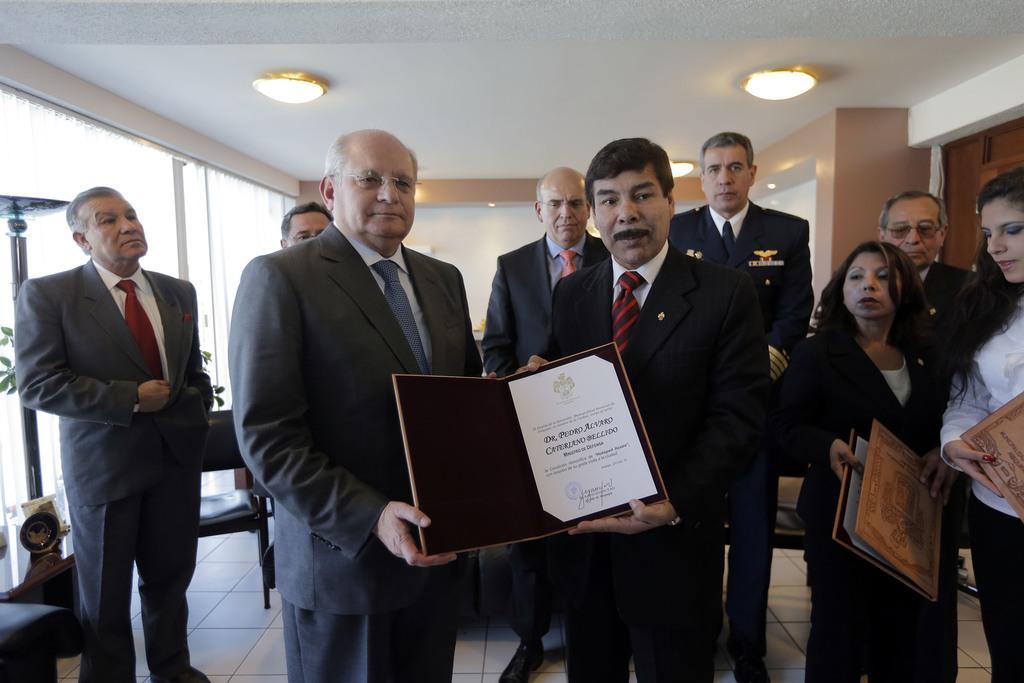How would you summarize this image in a sentence or two? In this picture I can see two persons standing and holding a padded certificate, there are group of people standing, there are two persons holding the padded certificates, there are some objects on the table, there is a chair, there is a plant, there are lights and curtains. 